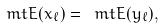<formula> <loc_0><loc_0><loc_500><loc_500>\ m t { E } ( x _ { \ell } ) = \ m t { E } ( y _ { \ell } ) ,</formula> 